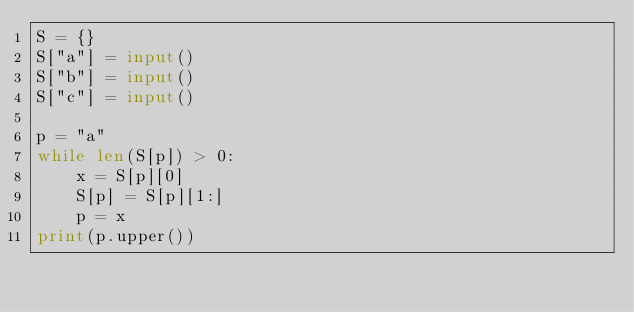Convert code to text. <code><loc_0><loc_0><loc_500><loc_500><_Python_>S = {}
S["a"] = input()
S["b"] = input()
S["c"] = input()

p = "a"
while len(S[p]) > 0:
    x = S[p][0]
    S[p] = S[p][1:]
    p = x
print(p.upper())</code> 